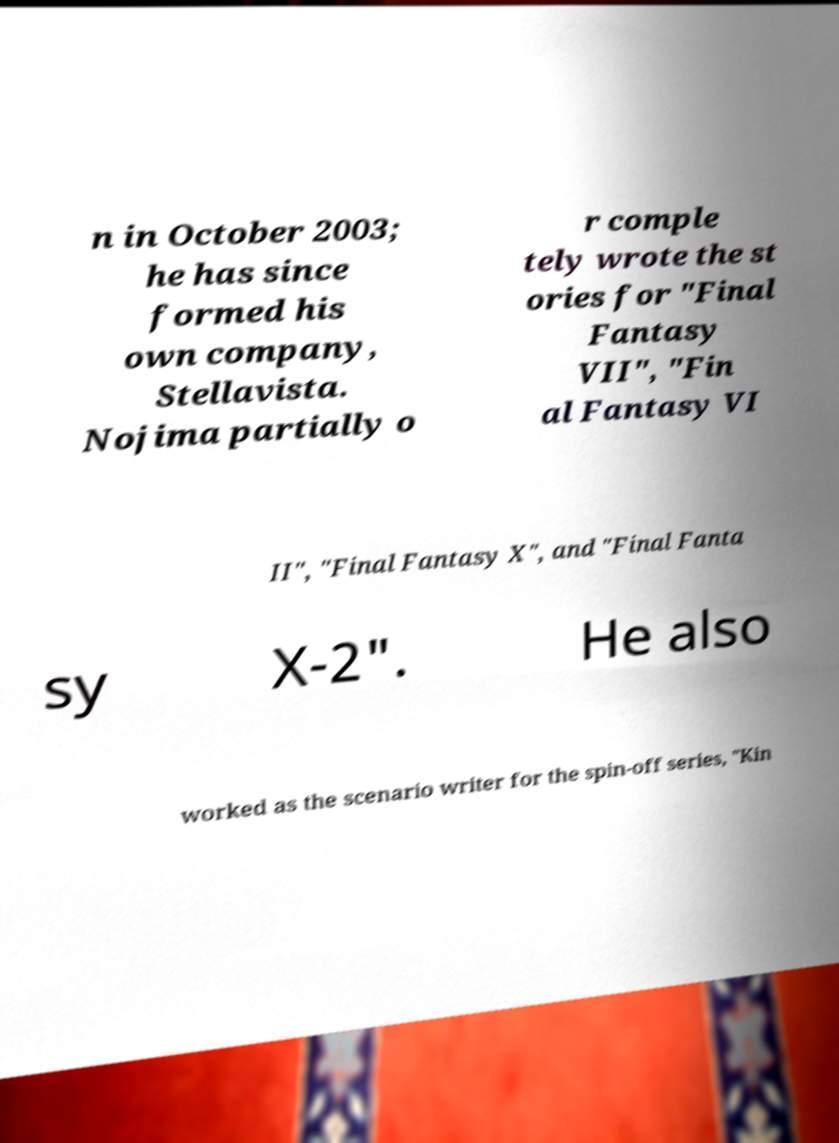I need the written content from this picture converted into text. Can you do that? n in October 2003; he has since formed his own company, Stellavista. Nojima partially o r comple tely wrote the st ories for "Final Fantasy VII", "Fin al Fantasy VI II", "Final Fantasy X", and "Final Fanta sy X-2". He also worked as the scenario writer for the spin-off series, "Kin 